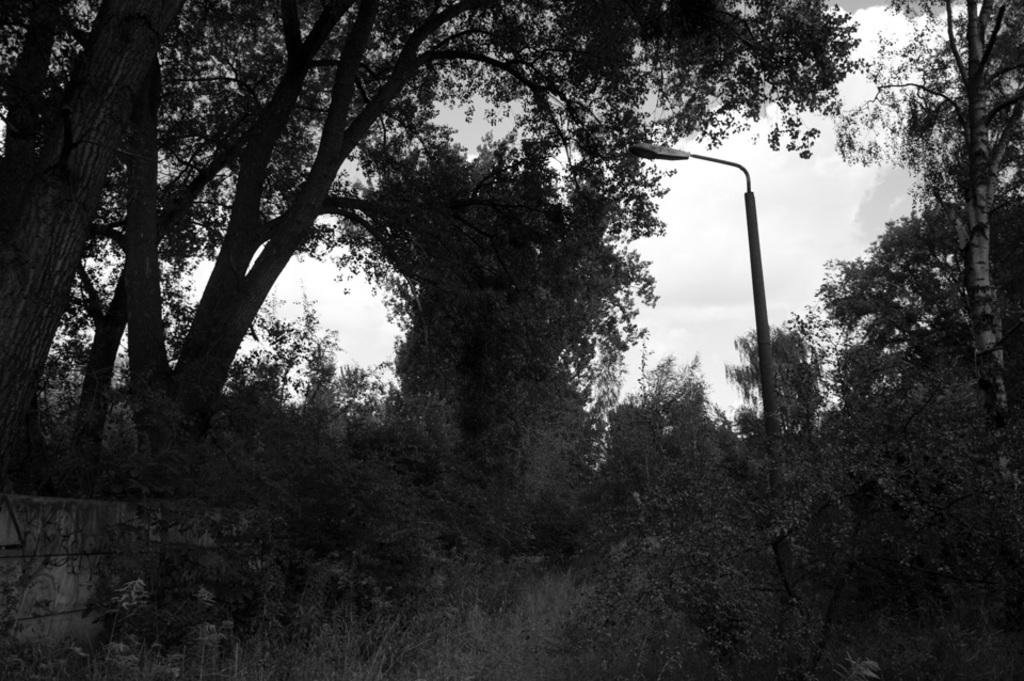What types of vegetation are present in the image? The image contains trees and plants. What is the color scheme of the image? The image is black and white. Can you describe the source of light in the image? There is light in the middle of the image. What type of yard is visible in the image? There is no yard present in the image; it contains trees and plants. What territory is being claimed by the light in the image? There is no territory being claimed by the light in the image; it is simply a source of illumination. 